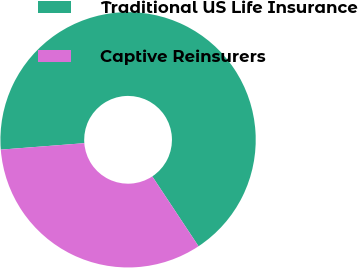<chart> <loc_0><loc_0><loc_500><loc_500><pie_chart><fcel>Traditional US Life Insurance<fcel>Captive Reinsurers<nl><fcel>66.92%<fcel>33.08%<nl></chart> 